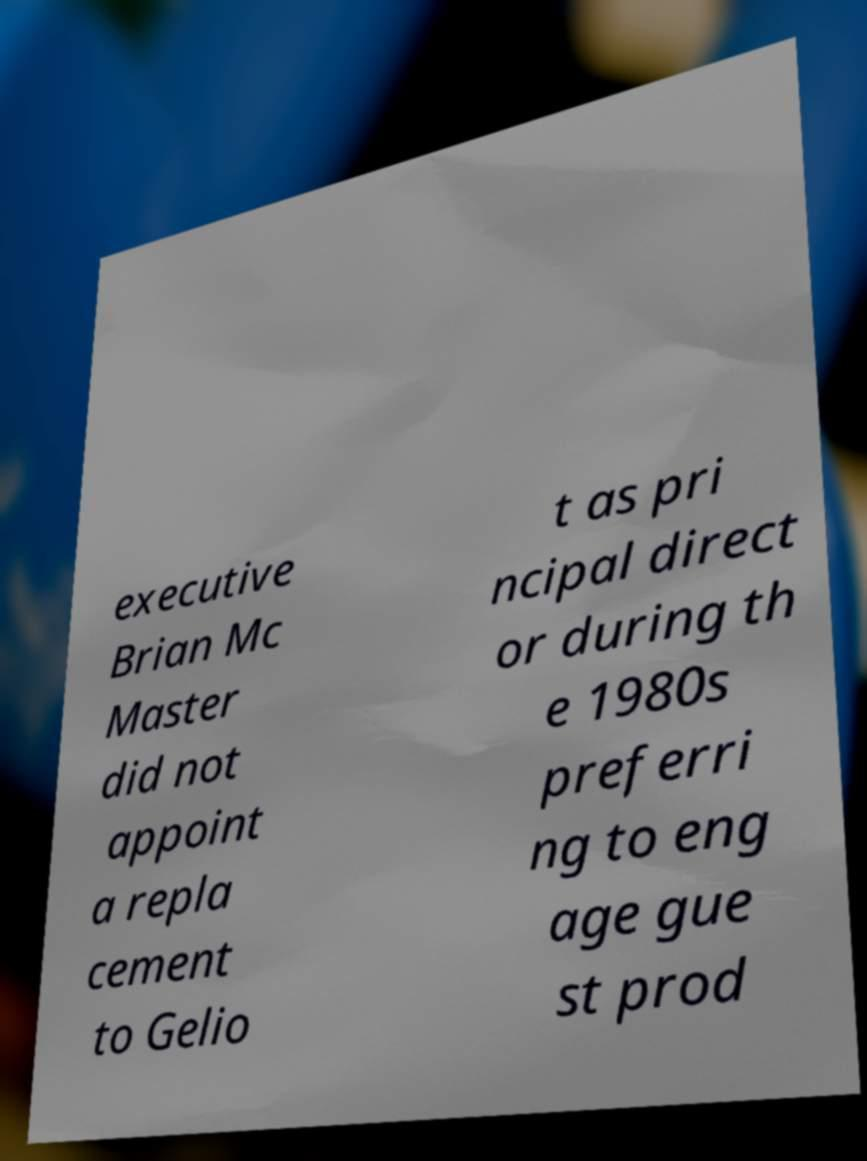Could you extract and type out the text from this image? executive Brian Mc Master did not appoint a repla cement to Gelio t as pri ncipal direct or during th e 1980s preferri ng to eng age gue st prod 